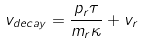Convert formula to latex. <formula><loc_0><loc_0><loc_500><loc_500>v _ { d e c a y } = \frac { p _ { r } \tau } { m _ { r } \kappa } + v _ { r }</formula> 